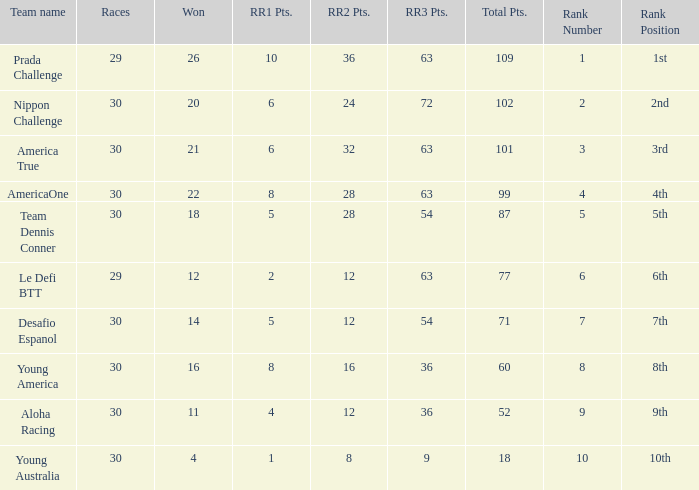Name the ranking for rr2 pts being 8 10.0. 